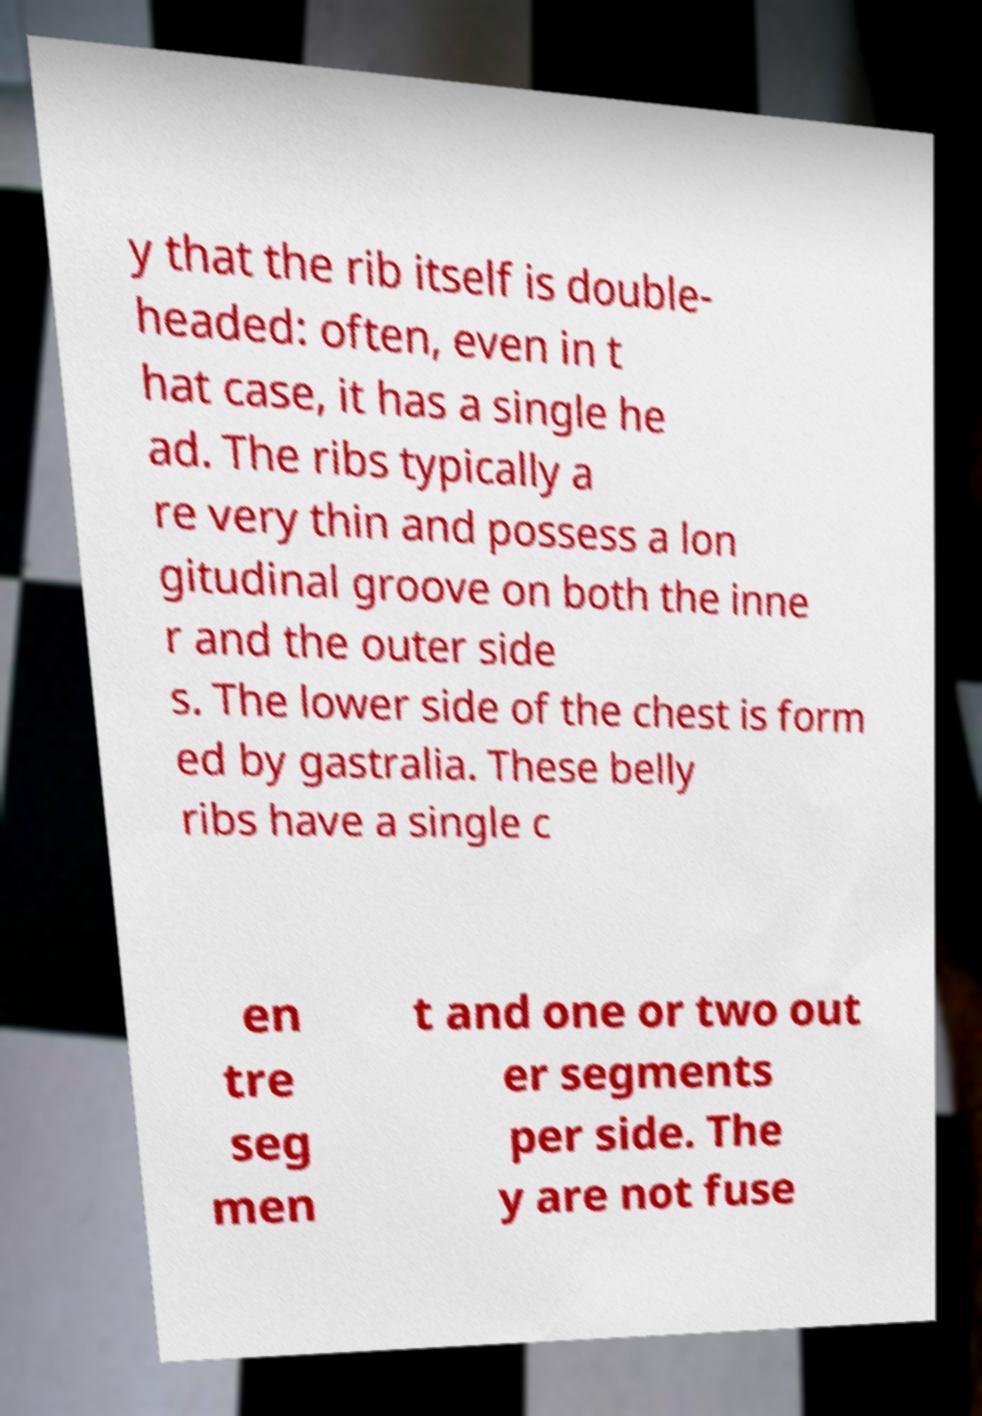Please read and relay the text visible in this image. What does it say? y that the rib itself is double- headed: often, even in t hat case, it has a single he ad. The ribs typically a re very thin and possess a lon gitudinal groove on both the inne r and the outer side s. The lower side of the chest is form ed by gastralia. These belly ribs have a single c en tre seg men t and one or two out er segments per side. The y are not fuse 